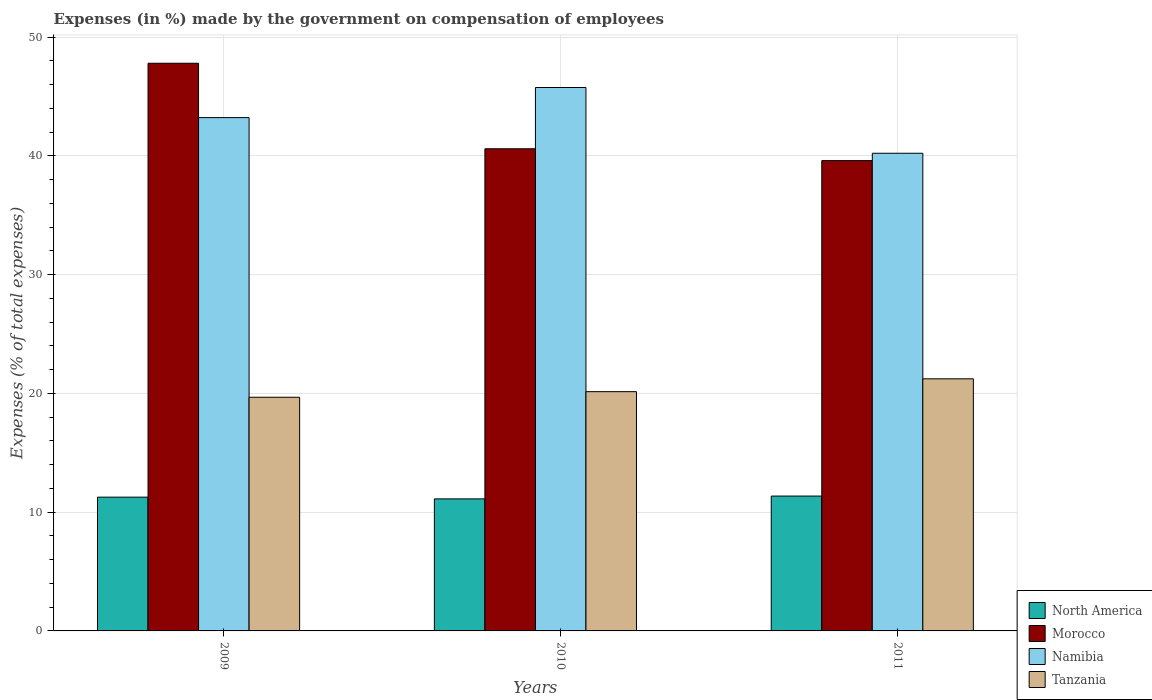Are the number of bars per tick equal to the number of legend labels?
Provide a short and direct response. Yes. How many bars are there on the 1st tick from the left?
Ensure brevity in your answer.  4. How many bars are there on the 3rd tick from the right?
Your response must be concise. 4. What is the label of the 1st group of bars from the left?
Give a very brief answer. 2009. In how many cases, is the number of bars for a given year not equal to the number of legend labels?
Provide a short and direct response. 0. What is the percentage of expenses made by the government on compensation of employees in Morocco in 2011?
Keep it short and to the point. 39.6. Across all years, what is the maximum percentage of expenses made by the government on compensation of employees in North America?
Your answer should be compact. 11.35. Across all years, what is the minimum percentage of expenses made by the government on compensation of employees in Morocco?
Make the answer very short. 39.6. What is the total percentage of expenses made by the government on compensation of employees in Morocco in the graph?
Give a very brief answer. 127.99. What is the difference between the percentage of expenses made by the government on compensation of employees in Namibia in 2009 and that in 2010?
Keep it short and to the point. -2.54. What is the difference between the percentage of expenses made by the government on compensation of employees in Tanzania in 2011 and the percentage of expenses made by the government on compensation of employees in Namibia in 2009?
Provide a succinct answer. -21.99. What is the average percentage of expenses made by the government on compensation of employees in Namibia per year?
Offer a very short reply. 43.06. In the year 2010, what is the difference between the percentage of expenses made by the government on compensation of employees in Tanzania and percentage of expenses made by the government on compensation of employees in Morocco?
Give a very brief answer. -20.45. What is the ratio of the percentage of expenses made by the government on compensation of employees in North America in 2009 to that in 2011?
Your response must be concise. 0.99. Is the percentage of expenses made by the government on compensation of employees in Morocco in 2009 less than that in 2011?
Provide a short and direct response. No. Is the difference between the percentage of expenses made by the government on compensation of employees in Tanzania in 2009 and 2011 greater than the difference between the percentage of expenses made by the government on compensation of employees in Morocco in 2009 and 2011?
Give a very brief answer. No. What is the difference between the highest and the second highest percentage of expenses made by the government on compensation of employees in North America?
Offer a terse response. 0.09. What is the difference between the highest and the lowest percentage of expenses made by the government on compensation of employees in Namibia?
Keep it short and to the point. 5.54. In how many years, is the percentage of expenses made by the government on compensation of employees in Tanzania greater than the average percentage of expenses made by the government on compensation of employees in Tanzania taken over all years?
Keep it short and to the point. 1. What does the 3rd bar from the left in 2010 represents?
Give a very brief answer. Namibia. What does the 3rd bar from the right in 2009 represents?
Give a very brief answer. Morocco. Is it the case that in every year, the sum of the percentage of expenses made by the government on compensation of employees in North America and percentage of expenses made by the government on compensation of employees in Morocco is greater than the percentage of expenses made by the government on compensation of employees in Tanzania?
Give a very brief answer. Yes. How many years are there in the graph?
Make the answer very short. 3. Are the values on the major ticks of Y-axis written in scientific E-notation?
Make the answer very short. No. Does the graph contain grids?
Offer a terse response. Yes. How many legend labels are there?
Keep it short and to the point. 4. How are the legend labels stacked?
Offer a very short reply. Vertical. What is the title of the graph?
Your response must be concise. Expenses (in %) made by the government on compensation of employees. What is the label or title of the X-axis?
Make the answer very short. Years. What is the label or title of the Y-axis?
Your response must be concise. Expenses (% of total expenses). What is the Expenses (% of total expenses) in North America in 2009?
Your response must be concise. 11.26. What is the Expenses (% of total expenses) of Morocco in 2009?
Your response must be concise. 47.8. What is the Expenses (% of total expenses) in Namibia in 2009?
Provide a succinct answer. 43.22. What is the Expenses (% of total expenses) of Tanzania in 2009?
Your answer should be very brief. 19.67. What is the Expenses (% of total expenses) in North America in 2010?
Your answer should be compact. 11.12. What is the Expenses (% of total expenses) in Morocco in 2010?
Your answer should be compact. 40.6. What is the Expenses (% of total expenses) in Namibia in 2010?
Ensure brevity in your answer.  45.76. What is the Expenses (% of total expenses) of Tanzania in 2010?
Provide a short and direct response. 20.14. What is the Expenses (% of total expenses) in North America in 2011?
Your response must be concise. 11.35. What is the Expenses (% of total expenses) of Morocco in 2011?
Provide a short and direct response. 39.6. What is the Expenses (% of total expenses) of Namibia in 2011?
Offer a terse response. 40.22. What is the Expenses (% of total expenses) in Tanzania in 2011?
Your answer should be very brief. 21.23. Across all years, what is the maximum Expenses (% of total expenses) in North America?
Provide a short and direct response. 11.35. Across all years, what is the maximum Expenses (% of total expenses) of Morocco?
Offer a terse response. 47.8. Across all years, what is the maximum Expenses (% of total expenses) of Namibia?
Provide a succinct answer. 45.76. Across all years, what is the maximum Expenses (% of total expenses) in Tanzania?
Provide a succinct answer. 21.23. Across all years, what is the minimum Expenses (% of total expenses) in North America?
Ensure brevity in your answer.  11.12. Across all years, what is the minimum Expenses (% of total expenses) of Morocco?
Provide a succinct answer. 39.6. Across all years, what is the minimum Expenses (% of total expenses) in Namibia?
Give a very brief answer. 40.22. Across all years, what is the minimum Expenses (% of total expenses) of Tanzania?
Provide a short and direct response. 19.67. What is the total Expenses (% of total expenses) of North America in the graph?
Offer a very short reply. 33.73. What is the total Expenses (% of total expenses) of Morocco in the graph?
Make the answer very short. 127.99. What is the total Expenses (% of total expenses) in Namibia in the graph?
Make the answer very short. 129.19. What is the total Expenses (% of total expenses) of Tanzania in the graph?
Your response must be concise. 61.05. What is the difference between the Expenses (% of total expenses) of North America in 2009 and that in 2010?
Your answer should be compact. 0.15. What is the difference between the Expenses (% of total expenses) in Morocco in 2009 and that in 2010?
Keep it short and to the point. 7.2. What is the difference between the Expenses (% of total expenses) of Namibia in 2009 and that in 2010?
Provide a succinct answer. -2.54. What is the difference between the Expenses (% of total expenses) in Tanzania in 2009 and that in 2010?
Offer a terse response. -0.47. What is the difference between the Expenses (% of total expenses) of North America in 2009 and that in 2011?
Ensure brevity in your answer.  -0.09. What is the difference between the Expenses (% of total expenses) of Morocco in 2009 and that in 2011?
Give a very brief answer. 8.2. What is the difference between the Expenses (% of total expenses) in Namibia in 2009 and that in 2011?
Provide a succinct answer. 3. What is the difference between the Expenses (% of total expenses) in Tanzania in 2009 and that in 2011?
Keep it short and to the point. -1.55. What is the difference between the Expenses (% of total expenses) in North America in 2010 and that in 2011?
Make the answer very short. -0.24. What is the difference between the Expenses (% of total expenses) in Morocco in 2010 and that in 2011?
Your answer should be compact. 1. What is the difference between the Expenses (% of total expenses) in Namibia in 2010 and that in 2011?
Offer a very short reply. 5.54. What is the difference between the Expenses (% of total expenses) in Tanzania in 2010 and that in 2011?
Your answer should be compact. -1.08. What is the difference between the Expenses (% of total expenses) of North America in 2009 and the Expenses (% of total expenses) of Morocco in 2010?
Make the answer very short. -29.33. What is the difference between the Expenses (% of total expenses) of North America in 2009 and the Expenses (% of total expenses) of Namibia in 2010?
Keep it short and to the point. -34.49. What is the difference between the Expenses (% of total expenses) of North America in 2009 and the Expenses (% of total expenses) of Tanzania in 2010?
Your answer should be very brief. -8.88. What is the difference between the Expenses (% of total expenses) of Morocco in 2009 and the Expenses (% of total expenses) of Namibia in 2010?
Your answer should be very brief. 2.04. What is the difference between the Expenses (% of total expenses) in Morocco in 2009 and the Expenses (% of total expenses) in Tanzania in 2010?
Ensure brevity in your answer.  27.65. What is the difference between the Expenses (% of total expenses) in Namibia in 2009 and the Expenses (% of total expenses) in Tanzania in 2010?
Provide a succinct answer. 23.07. What is the difference between the Expenses (% of total expenses) in North America in 2009 and the Expenses (% of total expenses) in Morocco in 2011?
Ensure brevity in your answer.  -28.34. What is the difference between the Expenses (% of total expenses) of North America in 2009 and the Expenses (% of total expenses) of Namibia in 2011?
Ensure brevity in your answer.  -28.96. What is the difference between the Expenses (% of total expenses) in North America in 2009 and the Expenses (% of total expenses) in Tanzania in 2011?
Your response must be concise. -9.96. What is the difference between the Expenses (% of total expenses) of Morocco in 2009 and the Expenses (% of total expenses) of Namibia in 2011?
Your response must be concise. 7.58. What is the difference between the Expenses (% of total expenses) in Morocco in 2009 and the Expenses (% of total expenses) in Tanzania in 2011?
Offer a terse response. 26.57. What is the difference between the Expenses (% of total expenses) of Namibia in 2009 and the Expenses (% of total expenses) of Tanzania in 2011?
Offer a very short reply. 21.99. What is the difference between the Expenses (% of total expenses) in North America in 2010 and the Expenses (% of total expenses) in Morocco in 2011?
Make the answer very short. -28.48. What is the difference between the Expenses (% of total expenses) of North America in 2010 and the Expenses (% of total expenses) of Namibia in 2011?
Offer a very short reply. -29.1. What is the difference between the Expenses (% of total expenses) in North America in 2010 and the Expenses (% of total expenses) in Tanzania in 2011?
Your response must be concise. -10.11. What is the difference between the Expenses (% of total expenses) in Morocco in 2010 and the Expenses (% of total expenses) in Namibia in 2011?
Your answer should be compact. 0.38. What is the difference between the Expenses (% of total expenses) in Morocco in 2010 and the Expenses (% of total expenses) in Tanzania in 2011?
Your answer should be very brief. 19.37. What is the difference between the Expenses (% of total expenses) of Namibia in 2010 and the Expenses (% of total expenses) of Tanzania in 2011?
Provide a succinct answer. 24.53. What is the average Expenses (% of total expenses) of North America per year?
Offer a terse response. 11.24. What is the average Expenses (% of total expenses) of Morocco per year?
Your response must be concise. 42.66. What is the average Expenses (% of total expenses) in Namibia per year?
Provide a short and direct response. 43.06. What is the average Expenses (% of total expenses) in Tanzania per year?
Provide a succinct answer. 20.35. In the year 2009, what is the difference between the Expenses (% of total expenses) in North America and Expenses (% of total expenses) in Morocco?
Your answer should be very brief. -36.53. In the year 2009, what is the difference between the Expenses (% of total expenses) in North America and Expenses (% of total expenses) in Namibia?
Your answer should be very brief. -31.96. In the year 2009, what is the difference between the Expenses (% of total expenses) in North America and Expenses (% of total expenses) in Tanzania?
Offer a terse response. -8.41. In the year 2009, what is the difference between the Expenses (% of total expenses) of Morocco and Expenses (% of total expenses) of Namibia?
Offer a very short reply. 4.58. In the year 2009, what is the difference between the Expenses (% of total expenses) in Morocco and Expenses (% of total expenses) in Tanzania?
Offer a very short reply. 28.12. In the year 2009, what is the difference between the Expenses (% of total expenses) of Namibia and Expenses (% of total expenses) of Tanzania?
Your answer should be compact. 23.55. In the year 2010, what is the difference between the Expenses (% of total expenses) of North America and Expenses (% of total expenses) of Morocco?
Give a very brief answer. -29.48. In the year 2010, what is the difference between the Expenses (% of total expenses) of North America and Expenses (% of total expenses) of Namibia?
Give a very brief answer. -34.64. In the year 2010, what is the difference between the Expenses (% of total expenses) of North America and Expenses (% of total expenses) of Tanzania?
Provide a succinct answer. -9.03. In the year 2010, what is the difference between the Expenses (% of total expenses) in Morocco and Expenses (% of total expenses) in Namibia?
Your answer should be very brief. -5.16. In the year 2010, what is the difference between the Expenses (% of total expenses) of Morocco and Expenses (% of total expenses) of Tanzania?
Provide a short and direct response. 20.45. In the year 2010, what is the difference between the Expenses (% of total expenses) of Namibia and Expenses (% of total expenses) of Tanzania?
Offer a terse response. 25.61. In the year 2011, what is the difference between the Expenses (% of total expenses) in North America and Expenses (% of total expenses) in Morocco?
Your answer should be compact. -28.25. In the year 2011, what is the difference between the Expenses (% of total expenses) in North America and Expenses (% of total expenses) in Namibia?
Your answer should be compact. -28.86. In the year 2011, what is the difference between the Expenses (% of total expenses) in North America and Expenses (% of total expenses) in Tanzania?
Your answer should be very brief. -9.87. In the year 2011, what is the difference between the Expenses (% of total expenses) of Morocco and Expenses (% of total expenses) of Namibia?
Offer a very short reply. -0.62. In the year 2011, what is the difference between the Expenses (% of total expenses) in Morocco and Expenses (% of total expenses) in Tanzania?
Provide a succinct answer. 18.37. In the year 2011, what is the difference between the Expenses (% of total expenses) in Namibia and Expenses (% of total expenses) in Tanzania?
Offer a terse response. 18.99. What is the ratio of the Expenses (% of total expenses) of North America in 2009 to that in 2010?
Make the answer very short. 1.01. What is the ratio of the Expenses (% of total expenses) in Morocco in 2009 to that in 2010?
Give a very brief answer. 1.18. What is the ratio of the Expenses (% of total expenses) in Namibia in 2009 to that in 2010?
Your answer should be compact. 0.94. What is the ratio of the Expenses (% of total expenses) in Tanzania in 2009 to that in 2010?
Your response must be concise. 0.98. What is the ratio of the Expenses (% of total expenses) in Morocco in 2009 to that in 2011?
Provide a succinct answer. 1.21. What is the ratio of the Expenses (% of total expenses) in Namibia in 2009 to that in 2011?
Ensure brevity in your answer.  1.07. What is the ratio of the Expenses (% of total expenses) of Tanzania in 2009 to that in 2011?
Give a very brief answer. 0.93. What is the ratio of the Expenses (% of total expenses) of North America in 2010 to that in 2011?
Keep it short and to the point. 0.98. What is the ratio of the Expenses (% of total expenses) of Morocco in 2010 to that in 2011?
Offer a very short reply. 1.03. What is the ratio of the Expenses (% of total expenses) in Namibia in 2010 to that in 2011?
Provide a succinct answer. 1.14. What is the ratio of the Expenses (% of total expenses) in Tanzania in 2010 to that in 2011?
Provide a succinct answer. 0.95. What is the difference between the highest and the second highest Expenses (% of total expenses) of North America?
Make the answer very short. 0.09. What is the difference between the highest and the second highest Expenses (% of total expenses) of Morocco?
Your answer should be very brief. 7.2. What is the difference between the highest and the second highest Expenses (% of total expenses) in Namibia?
Offer a terse response. 2.54. What is the difference between the highest and the second highest Expenses (% of total expenses) of Tanzania?
Provide a short and direct response. 1.08. What is the difference between the highest and the lowest Expenses (% of total expenses) in North America?
Your answer should be compact. 0.24. What is the difference between the highest and the lowest Expenses (% of total expenses) in Morocco?
Keep it short and to the point. 8.2. What is the difference between the highest and the lowest Expenses (% of total expenses) of Namibia?
Give a very brief answer. 5.54. What is the difference between the highest and the lowest Expenses (% of total expenses) of Tanzania?
Offer a very short reply. 1.55. 